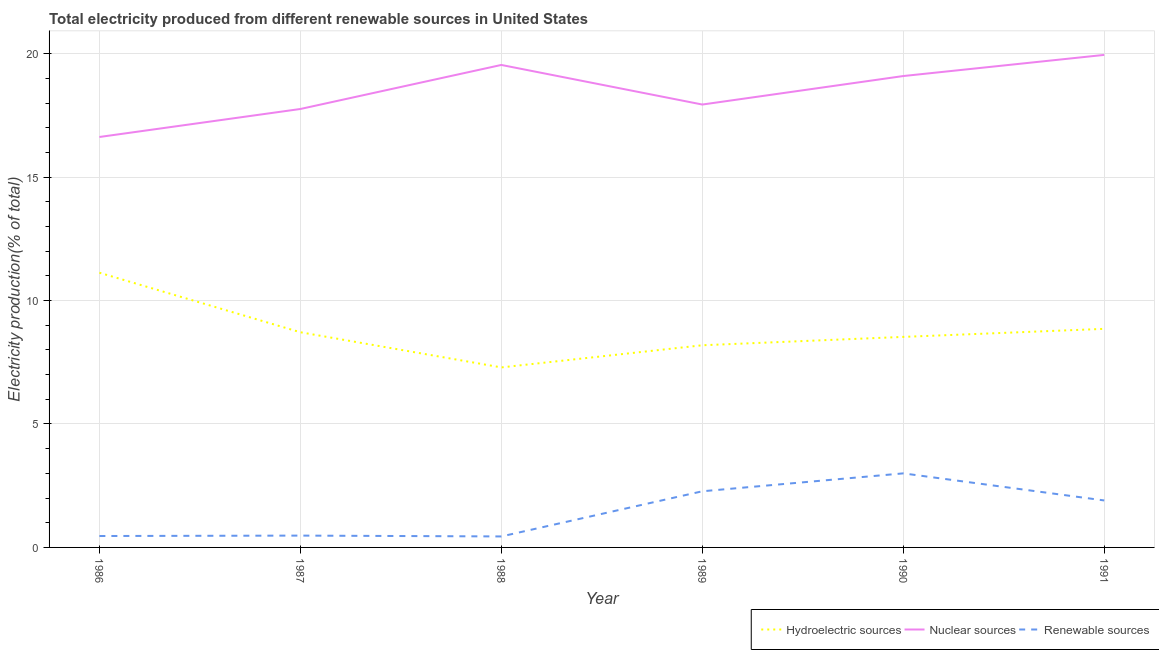How many different coloured lines are there?
Make the answer very short. 3. Is the number of lines equal to the number of legend labels?
Provide a short and direct response. Yes. What is the percentage of electricity produced by nuclear sources in 1987?
Offer a terse response. 17.76. Across all years, what is the maximum percentage of electricity produced by nuclear sources?
Provide a short and direct response. 19.95. Across all years, what is the minimum percentage of electricity produced by nuclear sources?
Ensure brevity in your answer.  16.63. In which year was the percentage of electricity produced by renewable sources minimum?
Give a very brief answer. 1988. What is the total percentage of electricity produced by hydroelectric sources in the graph?
Offer a terse response. 52.71. What is the difference between the percentage of electricity produced by renewable sources in 1987 and that in 1989?
Your answer should be very brief. -1.8. What is the difference between the percentage of electricity produced by nuclear sources in 1986 and the percentage of electricity produced by hydroelectric sources in 1991?
Offer a very short reply. 7.77. What is the average percentage of electricity produced by nuclear sources per year?
Your answer should be compact. 18.49. In the year 1990, what is the difference between the percentage of electricity produced by renewable sources and percentage of electricity produced by hydroelectric sources?
Your response must be concise. -5.53. In how many years, is the percentage of electricity produced by hydroelectric sources greater than 14 %?
Make the answer very short. 0. What is the ratio of the percentage of electricity produced by nuclear sources in 1986 to that in 1987?
Make the answer very short. 0.94. Is the difference between the percentage of electricity produced by renewable sources in 1988 and 1991 greater than the difference between the percentage of electricity produced by hydroelectric sources in 1988 and 1991?
Keep it short and to the point. Yes. What is the difference between the highest and the second highest percentage of electricity produced by hydroelectric sources?
Make the answer very short. 2.27. What is the difference between the highest and the lowest percentage of electricity produced by renewable sources?
Your answer should be very brief. 2.56. In how many years, is the percentage of electricity produced by nuclear sources greater than the average percentage of electricity produced by nuclear sources taken over all years?
Provide a short and direct response. 3. Is the sum of the percentage of electricity produced by nuclear sources in 1990 and 1991 greater than the maximum percentage of electricity produced by hydroelectric sources across all years?
Offer a terse response. Yes. Is the percentage of electricity produced by hydroelectric sources strictly greater than the percentage of electricity produced by renewable sources over the years?
Provide a succinct answer. Yes. Does the graph contain any zero values?
Keep it short and to the point. No. How many legend labels are there?
Provide a succinct answer. 3. What is the title of the graph?
Offer a very short reply. Total electricity produced from different renewable sources in United States. Does "Nuclear sources" appear as one of the legend labels in the graph?
Offer a very short reply. Yes. What is the label or title of the X-axis?
Ensure brevity in your answer.  Year. What is the Electricity production(% of total) in Hydroelectric sources in 1986?
Your answer should be very brief. 11.13. What is the Electricity production(% of total) in Nuclear sources in 1986?
Provide a succinct answer. 16.63. What is the Electricity production(% of total) in Renewable sources in 1986?
Provide a succinct answer. 0.46. What is the Electricity production(% of total) of Hydroelectric sources in 1987?
Your answer should be very brief. 8.72. What is the Electricity production(% of total) in Nuclear sources in 1987?
Your answer should be very brief. 17.76. What is the Electricity production(% of total) of Renewable sources in 1987?
Your answer should be compact. 0.48. What is the Electricity production(% of total) in Hydroelectric sources in 1988?
Give a very brief answer. 7.29. What is the Electricity production(% of total) in Nuclear sources in 1988?
Your answer should be compact. 19.54. What is the Electricity production(% of total) in Renewable sources in 1988?
Your answer should be very brief. 0.44. What is the Electricity production(% of total) of Hydroelectric sources in 1989?
Offer a very short reply. 8.19. What is the Electricity production(% of total) of Nuclear sources in 1989?
Your response must be concise. 17.94. What is the Electricity production(% of total) of Renewable sources in 1989?
Make the answer very short. 2.27. What is the Electricity production(% of total) of Hydroelectric sources in 1990?
Provide a short and direct response. 8.53. What is the Electricity production(% of total) in Nuclear sources in 1990?
Your answer should be compact. 19.1. What is the Electricity production(% of total) in Renewable sources in 1990?
Your response must be concise. 3. What is the Electricity production(% of total) in Hydroelectric sources in 1991?
Provide a succinct answer. 8.85. What is the Electricity production(% of total) in Nuclear sources in 1991?
Keep it short and to the point. 19.95. What is the Electricity production(% of total) of Renewable sources in 1991?
Your answer should be very brief. 1.9. Across all years, what is the maximum Electricity production(% of total) of Hydroelectric sources?
Your answer should be very brief. 11.13. Across all years, what is the maximum Electricity production(% of total) of Nuclear sources?
Your answer should be compact. 19.95. Across all years, what is the maximum Electricity production(% of total) in Renewable sources?
Give a very brief answer. 3. Across all years, what is the minimum Electricity production(% of total) of Hydroelectric sources?
Provide a succinct answer. 7.29. Across all years, what is the minimum Electricity production(% of total) in Nuclear sources?
Keep it short and to the point. 16.63. Across all years, what is the minimum Electricity production(% of total) in Renewable sources?
Provide a short and direct response. 0.44. What is the total Electricity production(% of total) of Hydroelectric sources in the graph?
Offer a terse response. 52.71. What is the total Electricity production(% of total) in Nuclear sources in the graph?
Provide a short and direct response. 110.92. What is the total Electricity production(% of total) of Renewable sources in the graph?
Your response must be concise. 8.56. What is the difference between the Electricity production(% of total) in Hydroelectric sources in 1986 and that in 1987?
Keep it short and to the point. 2.41. What is the difference between the Electricity production(% of total) in Nuclear sources in 1986 and that in 1987?
Ensure brevity in your answer.  -1.13. What is the difference between the Electricity production(% of total) in Renewable sources in 1986 and that in 1987?
Ensure brevity in your answer.  -0.02. What is the difference between the Electricity production(% of total) of Hydroelectric sources in 1986 and that in 1988?
Keep it short and to the point. 3.84. What is the difference between the Electricity production(% of total) in Nuclear sources in 1986 and that in 1988?
Offer a terse response. -2.92. What is the difference between the Electricity production(% of total) of Renewable sources in 1986 and that in 1988?
Give a very brief answer. 0.02. What is the difference between the Electricity production(% of total) of Hydroelectric sources in 1986 and that in 1989?
Offer a very short reply. 2.94. What is the difference between the Electricity production(% of total) of Nuclear sources in 1986 and that in 1989?
Your response must be concise. -1.31. What is the difference between the Electricity production(% of total) of Renewable sources in 1986 and that in 1989?
Your answer should be compact. -1.81. What is the difference between the Electricity production(% of total) in Hydroelectric sources in 1986 and that in 1990?
Your response must be concise. 2.6. What is the difference between the Electricity production(% of total) in Nuclear sources in 1986 and that in 1990?
Your answer should be very brief. -2.47. What is the difference between the Electricity production(% of total) of Renewable sources in 1986 and that in 1990?
Ensure brevity in your answer.  -2.54. What is the difference between the Electricity production(% of total) in Hydroelectric sources in 1986 and that in 1991?
Keep it short and to the point. 2.27. What is the difference between the Electricity production(% of total) of Nuclear sources in 1986 and that in 1991?
Ensure brevity in your answer.  -3.33. What is the difference between the Electricity production(% of total) in Renewable sources in 1986 and that in 1991?
Make the answer very short. -1.44. What is the difference between the Electricity production(% of total) in Hydroelectric sources in 1987 and that in 1988?
Ensure brevity in your answer.  1.42. What is the difference between the Electricity production(% of total) in Nuclear sources in 1987 and that in 1988?
Provide a short and direct response. -1.78. What is the difference between the Electricity production(% of total) of Renewable sources in 1987 and that in 1988?
Give a very brief answer. 0.03. What is the difference between the Electricity production(% of total) of Hydroelectric sources in 1987 and that in 1989?
Keep it short and to the point. 0.53. What is the difference between the Electricity production(% of total) of Nuclear sources in 1987 and that in 1989?
Offer a very short reply. -0.18. What is the difference between the Electricity production(% of total) in Renewable sources in 1987 and that in 1989?
Ensure brevity in your answer.  -1.8. What is the difference between the Electricity production(% of total) of Hydroelectric sources in 1987 and that in 1990?
Make the answer very short. 0.19. What is the difference between the Electricity production(% of total) of Nuclear sources in 1987 and that in 1990?
Offer a terse response. -1.33. What is the difference between the Electricity production(% of total) in Renewable sources in 1987 and that in 1990?
Provide a short and direct response. -2.52. What is the difference between the Electricity production(% of total) in Hydroelectric sources in 1987 and that in 1991?
Keep it short and to the point. -0.14. What is the difference between the Electricity production(% of total) in Nuclear sources in 1987 and that in 1991?
Give a very brief answer. -2.19. What is the difference between the Electricity production(% of total) in Renewable sources in 1987 and that in 1991?
Make the answer very short. -1.42. What is the difference between the Electricity production(% of total) of Hydroelectric sources in 1988 and that in 1989?
Keep it short and to the point. -0.9. What is the difference between the Electricity production(% of total) of Nuclear sources in 1988 and that in 1989?
Give a very brief answer. 1.6. What is the difference between the Electricity production(% of total) in Renewable sources in 1988 and that in 1989?
Your answer should be compact. -1.83. What is the difference between the Electricity production(% of total) in Hydroelectric sources in 1988 and that in 1990?
Offer a terse response. -1.24. What is the difference between the Electricity production(% of total) in Nuclear sources in 1988 and that in 1990?
Keep it short and to the point. 0.45. What is the difference between the Electricity production(% of total) of Renewable sources in 1988 and that in 1990?
Offer a terse response. -2.56. What is the difference between the Electricity production(% of total) of Hydroelectric sources in 1988 and that in 1991?
Provide a short and direct response. -1.56. What is the difference between the Electricity production(% of total) of Nuclear sources in 1988 and that in 1991?
Ensure brevity in your answer.  -0.41. What is the difference between the Electricity production(% of total) in Renewable sources in 1988 and that in 1991?
Provide a succinct answer. -1.46. What is the difference between the Electricity production(% of total) in Hydroelectric sources in 1989 and that in 1990?
Offer a very short reply. -0.34. What is the difference between the Electricity production(% of total) in Nuclear sources in 1989 and that in 1990?
Offer a terse response. -1.15. What is the difference between the Electricity production(% of total) in Renewable sources in 1989 and that in 1990?
Your answer should be very brief. -0.73. What is the difference between the Electricity production(% of total) in Hydroelectric sources in 1989 and that in 1991?
Give a very brief answer. -0.66. What is the difference between the Electricity production(% of total) of Nuclear sources in 1989 and that in 1991?
Your response must be concise. -2.01. What is the difference between the Electricity production(% of total) in Renewable sources in 1989 and that in 1991?
Ensure brevity in your answer.  0.37. What is the difference between the Electricity production(% of total) in Hydroelectric sources in 1990 and that in 1991?
Your response must be concise. -0.33. What is the difference between the Electricity production(% of total) of Nuclear sources in 1990 and that in 1991?
Offer a terse response. -0.86. What is the difference between the Electricity production(% of total) in Renewable sources in 1990 and that in 1991?
Make the answer very short. 1.1. What is the difference between the Electricity production(% of total) of Hydroelectric sources in 1986 and the Electricity production(% of total) of Nuclear sources in 1987?
Your response must be concise. -6.63. What is the difference between the Electricity production(% of total) of Hydroelectric sources in 1986 and the Electricity production(% of total) of Renewable sources in 1987?
Your answer should be compact. 10.65. What is the difference between the Electricity production(% of total) in Nuclear sources in 1986 and the Electricity production(% of total) in Renewable sources in 1987?
Your answer should be very brief. 16.15. What is the difference between the Electricity production(% of total) in Hydroelectric sources in 1986 and the Electricity production(% of total) in Nuclear sources in 1988?
Keep it short and to the point. -8.42. What is the difference between the Electricity production(% of total) in Hydroelectric sources in 1986 and the Electricity production(% of total) in Renewable sources in 1988?
Your answer should be very brief. 10.68. What is the difference between the Electricity production(% of total) of Nuclear sources in 1986 and the Electricity production(% of total) of Renewable sources in 1988?
Offer a very short reply. 16.18. What is the difference between the Electricity production(% of total) in Hydroelectric sources in 1986 and the Electricity production(% of total) in Nuclear sources in 1989?
Make the answer very short. -6.81. What is the difference between the Electricity production(% of total) of Hydroelectric sources in 1986 and the Electricity production(% of total) of Renewable sources in 1989?
Make the answer very short. 8.85. What is the difference between the Electricity production(% of total) in Nuclear sources in 1986 and the Electricity production(% of total) in Renewable sources in 1989?
Your answer should be compact. 14.35. What is the difference between the Electricity production(% of total) of Hydroelectric sources in 1986 and the Electricity production(% of total) of Nuclear sources in 1990?
Your response must be concise. -7.97. What is the difference between the Electricity production(% of total) in Hydroelectric sources in 1986 and the Electricity production(% of total) in Renewable sources in 1990?
Give a very brief answer. 8.13. What is the difference between the Electricity production(% of total) in Nuclear sources in 1986 and the Electricity production(% of total) in Renewable sources in 1990?
Provide a succinct answer. 13.63. What is the difference between the Electricity production(% of total) in Hydroelectric sources in 1986 and the Electricity production(% of total) in Nuclear sources in 1991?
Offer a very short reply. -8.82. What is the difference between the Electricity production(% of total) in Hydroelectric sources in 1986 and the Electricity production(% of total) in Renewable sources in 1991?
Keep it short and to the point. 9.23. What is the difference between the Electricity production(% of total) of Nuclear sources in 1986 and the Electricity production(% of total) of Renewable sources in 1991?
Keep it short and to the point. 14.72. What is the difference between the Electricity production(% of total) in Hydroelectric sources in 1987 and the Electricity production(% of total) in Nuclear sources in 1988?
Provide a succinct answer. -10.83. What is the difference between the Electricity production(% of total) of Hydroelectric sources in 1987 and the Electricity production(% of total) of Renewable sources in 1988?
Make the answer very short. 8.27. What is the difference between the Electricity production(% of total) of Nuclear sources in 1987 and the Electricity production(% of total) of Renewable sources in 1988?
Keep it short and to the point. 17.32. What is the difference between the Electricity production(% of total) of Hydroelectric sources in 1987 and the Electricity production(% of total) of Nuclear sources in 1989?
Give a very brief answer. -9.22. What is the difference between the Electricity production(% of total) of Hydroelectric sources in 1987 and the Electricity production(% of total) of Renewable sources in 1989?
Your response must be concise. 6.44. What is the difference between the Electricity production(% of total) in Nuclear sources in 1987 and the Electricity production(% of total) in Renewable sources in 1989?
Give a very brief answer. 15.49. What is the difference between the Electricity production(% of total) in Hydroelectric sources in 1987 and the Electricity production(% of total) in Nuclear sources in 1990?
Offer a terse response. -10.38. What is the difference between the Electricity production(% of total) in Hydroelectric sources in 1987 and the Electricity production(% of total) in Renewable sources in 1990?
Your answer should be very brief. 5.72. What is the difference between the Electricity production(% of total) in Nuclear sources in 1987 and the Electricity production(% of total) in Renewable sources in 1990?
Ensure brevity in your answer.  14.76. What is the difference between the Electricity production(% of total) of Hydroelectric sources in 1987 and the Electricity production(% of total) of Nuclear sources in 1991?
Keep it short and to the point. -11.23. What is the difference between the Electricity production(% of total) in Hydroelectric sources in 1987 and the Electricity production(% of total) in Renewable sources in 1991?
Your answer should be very brief. 6.81. What is the difference between the Electricity production(% of total) in Nuclear sources in 1987 and the Electricity production(% of total) in Renewable sources in 1991?
Offer a very short reply. 15.86. What is the difference between the Electricity production(% of total) of Hydroelectric sources in 1988 and the Electricity production(% of total) of Nuclear sources in 1989?
Your response must be concise. -10.65. What is the difference between the Electricity production(% of total) of Hydroelectric sources in 1988 and the Electricity production(% of total) of Renewable sources in 1989?
Your answer should be compact. 5.02. What is the difference between the Electricity production(% of total) of Nuclear sources in 1988 and the Electricity production(% of total) of Renewable sources in 1989?
Your answer should be very brief. 17.27. What is the difference between the Electricity production(% of total) in Hydroelectric sources in 1988 and the Electricity production(% of total) in Nuclear sources in 1990?
Provide a succinct answer. -11.8. What is the difference between the Electricity production(% of total) in Hydroelectric sources in 1988 and the Electricity production(% of total) in Renewable sources in 1990?
Your answer should be very brief. 4.29. What is the difference between the Electricity production(% of total) in Nuclear sources in 1988 and the Electricity production(% of total) in Renewable sources in 1990?
Offer a terse response. 16.54. What is the difference between the Electricity production(% of total) in Hydroelectric sources in 1988 and the Electricity production(% of total) in Nuclear sources in 1991?
Keep it short and to the point. -12.66. What is the difference between the Electricity production(% of total) in Hydroelectric sources in 1988 and the Electricity production(% of total) in Renewable sources in 1991?
Provide a succinct answer. 5.39. What is the difference between the Electricity production(% of total) in Nuclear sources in 1988 and the Electricity production(% of total) in Renewable sources in 1991?
Your response must be concise. 17.64. What is the difference between the Electricity production(% of total) in Hydroelectric sources in 1989 and the Electricity production(% of total) in Nuclear sources in 1990?
Provide a succinct answer. -10.91. What is the difference between the Electricity production(% of total) in Hydroelectric sources in 1989 and the Electricity production(% of total) in Renewable sources in 1990?
Provide a succinct answer. 5.19. What is the difference between the Electricity production(% of total) in Nuclear sources in 1989 and the Electricity production(% of total) in Renewable sources in 1990?
Your response must be concise. 14.94. What is the difference between the Electricity production(% of total) of Hydroelectric sources in 1989 and the Electricity production(% of total) of Nuclear sources in 1991?
Your answer should be compact. -11.76. What is the difference between the Electricity production(% of total) in Hydroelectric sources in 1989 and the Electricity production(% of total) in Renewable sources in 1991?
Ensure brevity in your answer.  6.29. What is the difference between the Electricity production(% of total) in Nuclear sources in 1989 and the Electricity production(% of total) in Renewable sources in 1991?
Provide a succinct answer. 16.04. What is the difference between the Electricity production(% of total) in Hydroelectric sources in 1990 and the Electricity production(% of total) in Nuclear sources in 1991?
Ensure brevity in your answer.  -11.42. What is the difference between the Electricity production(% of total) of Hydroelectric sources in 1990 and the Electricity production(% of total) of Renewable sources in 1991?
Your answer should be compact. 6.63. What is the difference between the Electricity production(% of total) of Nuclear sources in 1990 and the Electricity production(% of total) of Renewable sources in 1991?
Your answer should be compact. 17.19. What is the average Electricity production(% of total) of Hydroelectric sources per year?
Your answer should be very brief. 8.78. What is the average Electricity production(% of total) of Nuclear sources per year?
Your answer should be very brief. 18.49. What is the average Electricity production(% of total) in Renewable sources per year?
Offer a very short reply. 1.43. In the year 1986, what is the difference between the Electricity production(% of total) in Hydroelectric sources and Electricity production(% of total) in Nuclear sources?
Ensure brevity in your answer.  -5.5. In the year 1986, what is the difference between the Electricity production(% of total) in Hydroelectric sources and Electricity production(% of total) in Renewable sources?
Your answer should be very brief. 10.67. In the year 1986, what is the difference between the Electricity production(% of total) in Nuclear sources and Electricity production(% of total) in Renewable sources?
Offer a terse response. 16.16. In the year 1987, what is the difference between the Electricity production(% of total) of Hydroelectric sources and Electricity production(% of total) of Nuclear sources?
Your response must be concise. -9.04. In the year 1987, what is the difference between the Electricity production(% of total) in Hydroelectric sources and Electricity production(% of total) in Renewable sources?
Provide a succinct answer. 8.24. In the year 1987, what is the difference between the Electricity production(% of total) of Nuclear sources and Electricity production(% of total) of Renewable sources?
Keep it short and to the point. 17.28. In the year 1988, what is the difference between the Electricity production(% of total) of Hydroelectric sources and Electricity production(% of total) of Nuclear sources?
Your answer should be very brief. -12.25. In the year 1988, what is the difference between the Electricity production(% of total) in Hydroelectric sources and Electricity production(% of total) in Renewable sources?
Give a very brief answer. 6.85. In the year 1988, what is the difference between the Electricity production(% of total) of Nuclear sources and Electricity production(% of total) of Renewable sources?
Offer a terse response. 19.1. In the year 1989, what is the difference between the Electricity production(% of total) in Hydroelectric sources and Electricity production(% of total) in Nuclear sources?
Your answer should be very brief. -9.75. In the year 1989, what is the difference between the Electricity production(% of total) in Hydroelectric sources and Electricity production(% of total) in Renewable sources?
Keep it short and to the point. 5.92. In the year 1989, what is the difference between the Electricity production(% of total) of Nuclear sources and Electricity production(% of total) of Renewable sources?
Provide a short and direct response. 15.67. In the year 1990, what is the difference between the Electricity production(% of total) of Hydroelectric sources and Electricity production(% of total) of Nuclear sources?
Provide a short and direct response. -10.57. In the year 1990, what is the difference between the Electricity production(% of total) in Hydroelectric sources and Electricity production(% of total) in Renewable sources?
Your answer should be very brief. 5.53. In the year 1990, what is the difference between the Electricity production(% of total) in Nuclear sources and Electricity production(% of total) in Renewable sources?
Offer a terse response. 16.1. In the year 1991, what is the difference between the Electricity production(% of total) in Hydroelectric sources and Electricity production(% of total) in Nuclear sources?
Ensure brevity in your answer.  -11.1. In the year 1991, what is the difference between the Electricity production(% of total) in Hydroelectric sources and Electricity production(% of total) in Renewable sources?
Offer a terse response. 6.95. In the year 1991, what is the difference between the Electricity production(% of total) in Nuclear sources and Electricity production(% of total) in Renewable sources?
Your answer should be very brief. 18.05. What is the ratio of the Electricity production(% of total) in Hydroelectric sources in 1986 to that in 1987?
Make the answer very short. 1.28. What is the ratio of the Electricity production(% of total) of Nuclear sources in 1986 to that in 1987?
Offer a terse response. 0.94. What is the ratio of the Electricity production(% of total) of Renewable sources in 1986 to that in 1987?
Keep it short and to the point. 0.97. What is the ratio of the Electricity production(% of total) of Hydroelectric sources in 1986 to that in 1988?
Your answer should be compact. 1.53. What is the ratio of the Electricity production(% of total) in Nuclear sources in 1986 to that in 1988?
Keep it short and to the point. 0.85. What is the ratio of the Electricity production(% of total) in Renewable sources in 1986 to that in 1988?
Make the answer very short. 1.04. What is the ratio of the Electricity production(% of total) in Hydroelectric sources in 1986 to that in 1989?
Keep it short and to the point. 1.36. What is the ratio of the Electricity production(% of total) of Nuclear sources in 1986 to that in 1989?
Ensure brevity in your answer.  0.93. What is the ratio of the Electricity production(% of total) of Renewable sources in 1986 to that in 1989?
Provide a succinct answer. 0.2. What is the ratio of the Electricity production(% of total) of Hydroelectric sources in 1986 to that in 1990?
Provide a short and direct response. 1.3. What is the ratio of the Electricity production(% of total) of Nuclear sources in 1986 to that in 1990?
Your answer should be compact. 0.87. What is the ratio of the Electricity production(% of total) of Renewable sources in 1986 to that in 1990?
Keep it short and to the point. 0.15. What is the ratio of the Electricity production(% of total) in Hydroelectric sources in 1986 to that in 1991?
Make the answer very short. 1.26. What is the ratio of the Electricity production(% of total) of Renewable sources in 1986 to that in 1991?
Offer a terse response. 0.24. What is the ratio of the Electricity production(% of total) of Hydroelectric sources in 1987 to that in 1988?
Make the answer very short. 1.2. What is the ratio of the Electricity production(% of total) in Nuclear sources in 1987 to that in 1988?
Give a very brief answer. 0.91. What is the ratio of the Electricity production(% of total) in Renewable sources in 1987 to that in 1988?
Keep it short and to the point. 1.08. What is the ratio of the Electricity production(% of total) of Hydroelectric sources in 1987 to that in 1989?
Your response must be concise. 1.06. What is the ratio of the Electricity production(% of total) in Renewable sources in 1987 to that in 1989?
Give a very brief answer. 0.21. What is the ratio of the Electricity production(% of total) in Hydroelectric sources in 1987 to that in 1990?
Provide a short and direct response. 1.02. What is the ratio of the Electricity production(% of total) of Nuclear sources in 1987 to that in 1990?
Your answer should be compact. 0.93. What is the ratio of the Electricity production(% of total) in Renewable sources in 1987 to that in 1990?
Ensure brevity in your answer.  0.16. What is the ratio of the Electricity production(% of total) in Hydroelectric sources in 1987 to that in 1991?
Offer a very short reply. 0.98. What is the ratio of the Electricity production(% of total) in Nuclear sources in 1987 to that in 1991?
Your response must be concise. 0.89. What is the ratio of the Electricity production(% of total) in Renewable sources in 1987 to that in 1991?
Keep it short and to the point. 0.25. What is the ratio of the Electricity production(% of total) of Hydroelectric sources in 1988 to that in 1989?
Give a very brief answer. 0.89. What is the ratio of the Electricity production(% of total) in Nuclear sources in 1988 to that in 1989?
Provide a short and direct response. 1.09. What is the ratio of the Electricity production(% of total) of Renewable sources in 1988 to that in 1989?
Provide a succinct answer. 0.2. What is the ratio of the Electricity production(% of total) in Hydroelectric sources in 1988 to that in 1990?
Keep it short and to the point. 0.85. What is the ratio of the Electricity production(% of total) in Nuclear sources in 1988 to that in 1990?
Your response must be concise. 1.02. What is the ratio of the Electricity production(% of total) in Renewable sources in 1988 to that in 1990?
Your answer should be very brief. 0.15. What is the ratio of the Electricity production(% of total) in Hydroelectric sources in 1988 to that in 1991?
Provide a short and direct response. 0.82. What is the ratio of the Electricity production(% of total) in Nuclear sources in 1988 to that in 1991?
Your response must be concise. 0.98. What is the ratio of the Electricity production(% of total) of Renewable sources in 1988 to that in 1991?
Give a very brief answer. 0.23. What is the ratio of the Electricity production(% of total) of Hydroelectric sources in 1989 to that in 1990?
Keep it short and to the point. 0.96. What is the ratio of the Electricity production(% of total) in Nuclear sources in 1989 to that in 1990?
Your answer should be compact. 0.94. What is the ratio of the Electricity production(% of total) in Renewable sources in 1989 to that in 1990?
Your response must be concise. 0.76. What is the ratio of the Electricity production(% of total) in Hydroelectric sources in 1989 to that in 1991?
Give a very brief answer. 0.92. What is the ratio of the Electricity production(% of total) in Nuclear sources in 1989 to that in 1991?
Provide a succinct answer. 0.9. What is the ratio of the Electricity production(% of total) of Renewable sources in 1989 to that in 1991?
Your answer should be compact. 1.2. What is the ratio of the Electricity production(% of total) of Hydroelectric sources in 1990 to that in 1991?
Give a very brief answer. 0.96. What is the ratio of the Electricity production(% of total) of Nuclear sources in 1990 to that in 1991?
Provide a short and direct response. 0.96. What is the ratio of the Electricity production(% of total) of Renewable sources in 1990 to that in 1991?
Offer a very short reply. 1.58. What is the difference between the highest and the second highest Electricity production(% of total) in Hydroelectric sources?
Your answer should be very brief. 2.27. What is the difference between the highest and the second highest Electricity production(% of total) of Nuclear sources?
Your answer should be very brief. 0.41. What is the difference between the highest and the second highest Electricity production(% of total) in Renewable sources?
Offer a terse response. 0.73. What is the difference between the highest and the lowest Electricity production(% of total) of Hydroelectric sources?
Your answer should be very brief. 3.84. What is the difference between the highest and the lowest Electricity production(% of total) of Nuclear sources?
Provide a short and direct response. 3.33. What is the difference between the highest and the lowest Electricity production(% of total) in Renewable sources?
Keep it short and to the point. 2.56. 